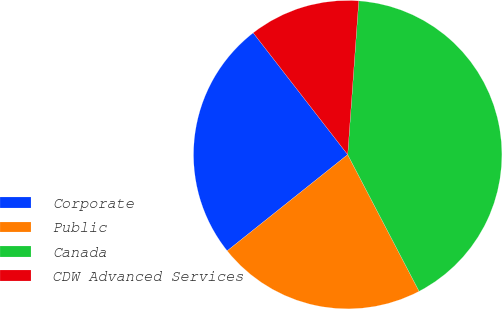<chart> <loc_0><loc_0><loc_500><loc_500><pie_chart><fcel>Corporate<fcel>Public<fcel>Canada<fcel>CDW Advanced Services<nl><fcel>25.22%<fcel>21.94%<fcel>41.19%<fcel>11.64%<nl></chart> 